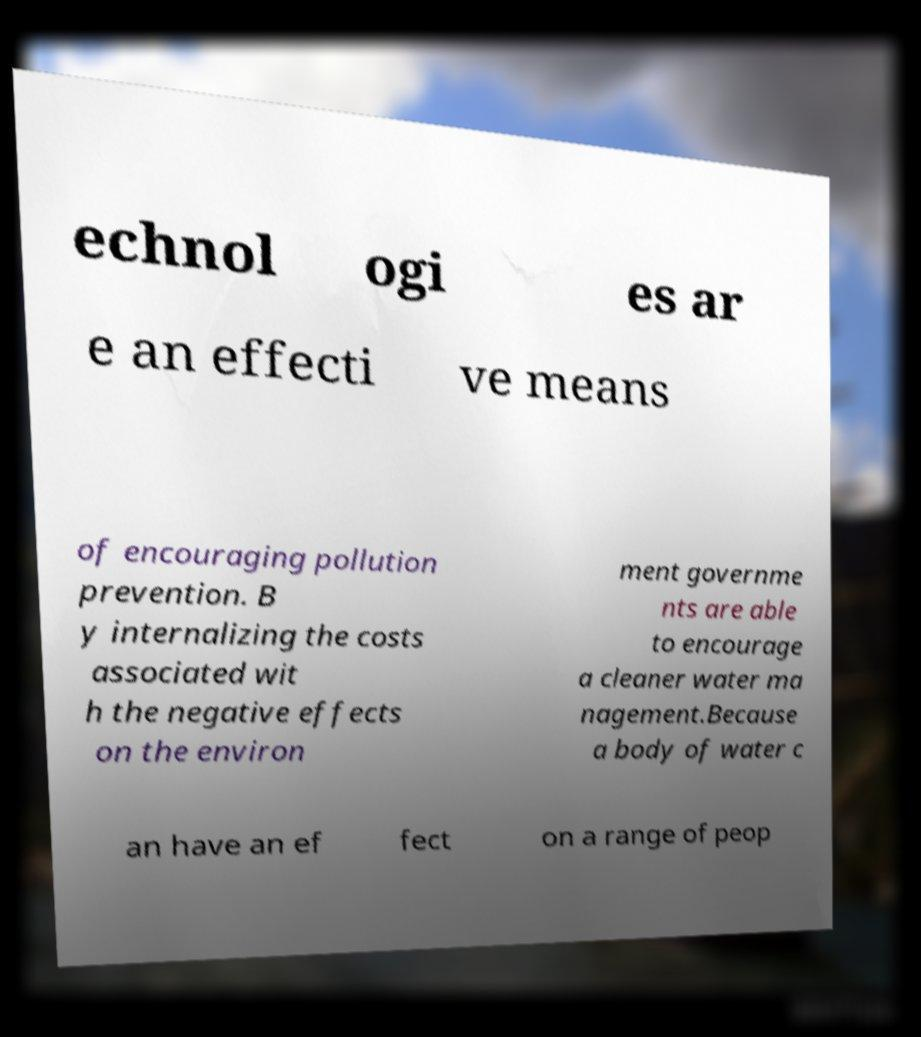Could you assist in decoding the text presented in this image and type it out clearly? echnol ogi es ar e an effecti ve means of encouraging pollution prevention. B y internalizing the costs associated wit h the negative effects on the environ ment governme nts are able to encourage a cleaner water ma nagement.Because a body of water c an have an ef fect on a range of peop 